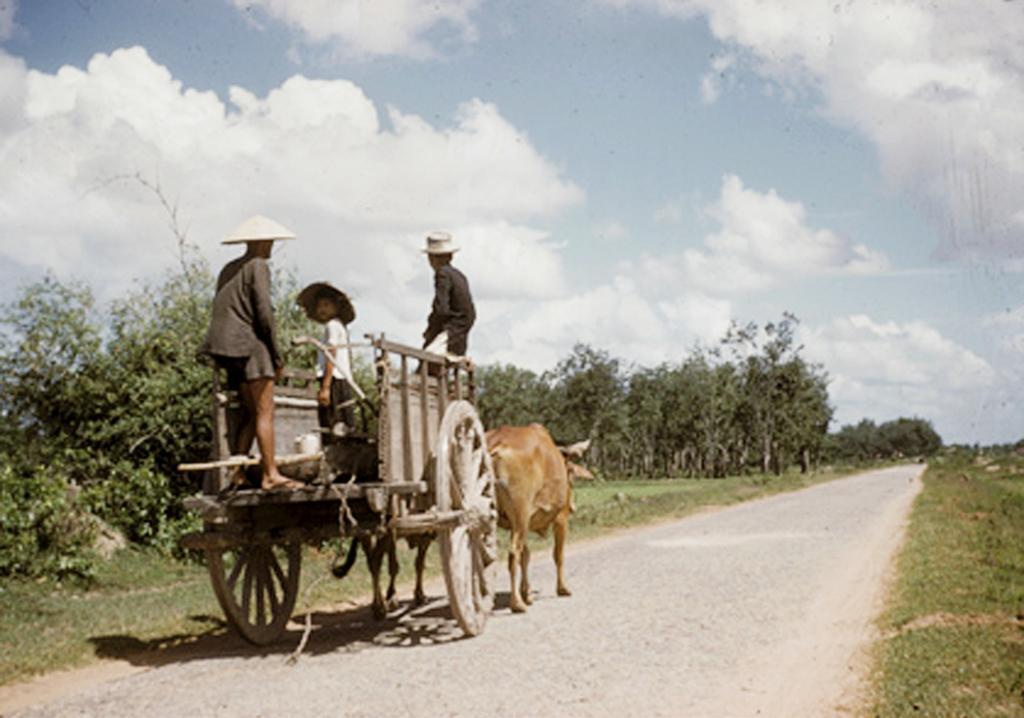Please provide a concise description of this image. In this picture there are people in the on the cow cart in the image and there are trees in the image. 